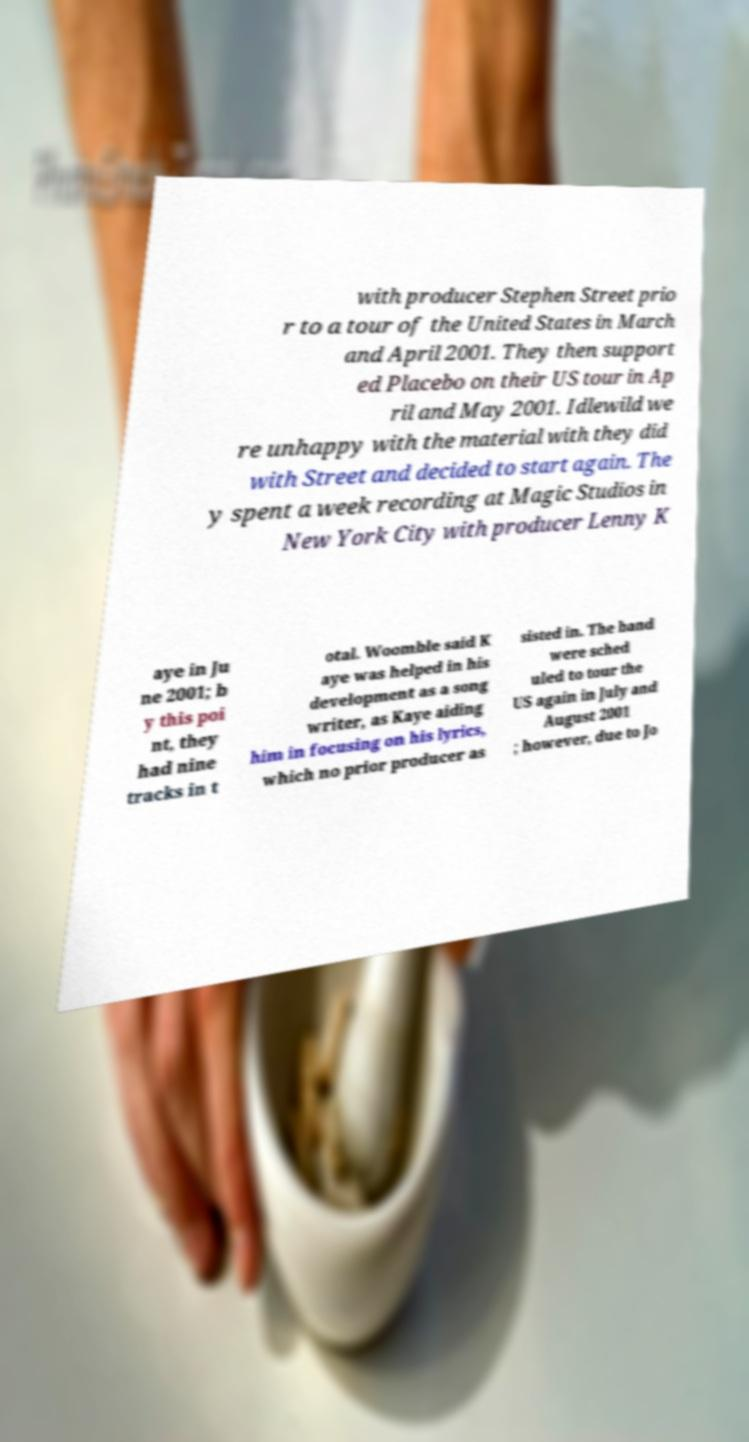Can you read and provide the text displayed in the image?This photo seems to have some interesting text. Can you extract and type it out for me? with producer Stephen Street prio r to a tour of the United States in March and April 2001. They then support ed Placebo on their US tour in Ap ril and May 2001. Idlewild we re unhappy with the material with they did with Street and decided to start again. The y spent a week recording at Magic Studios in New York City with producer Lenny K aye in Ju ne 2001; b y this poi nt, they had nine tracks in t otal. Woomble said K aye was helped in his development as a song writer, as Kaye aiding him in focusing on his lyrics, which no prior producer as sisted in. The band were sched uled to tour the US again in July and August 2001 ; however, due to Jo 